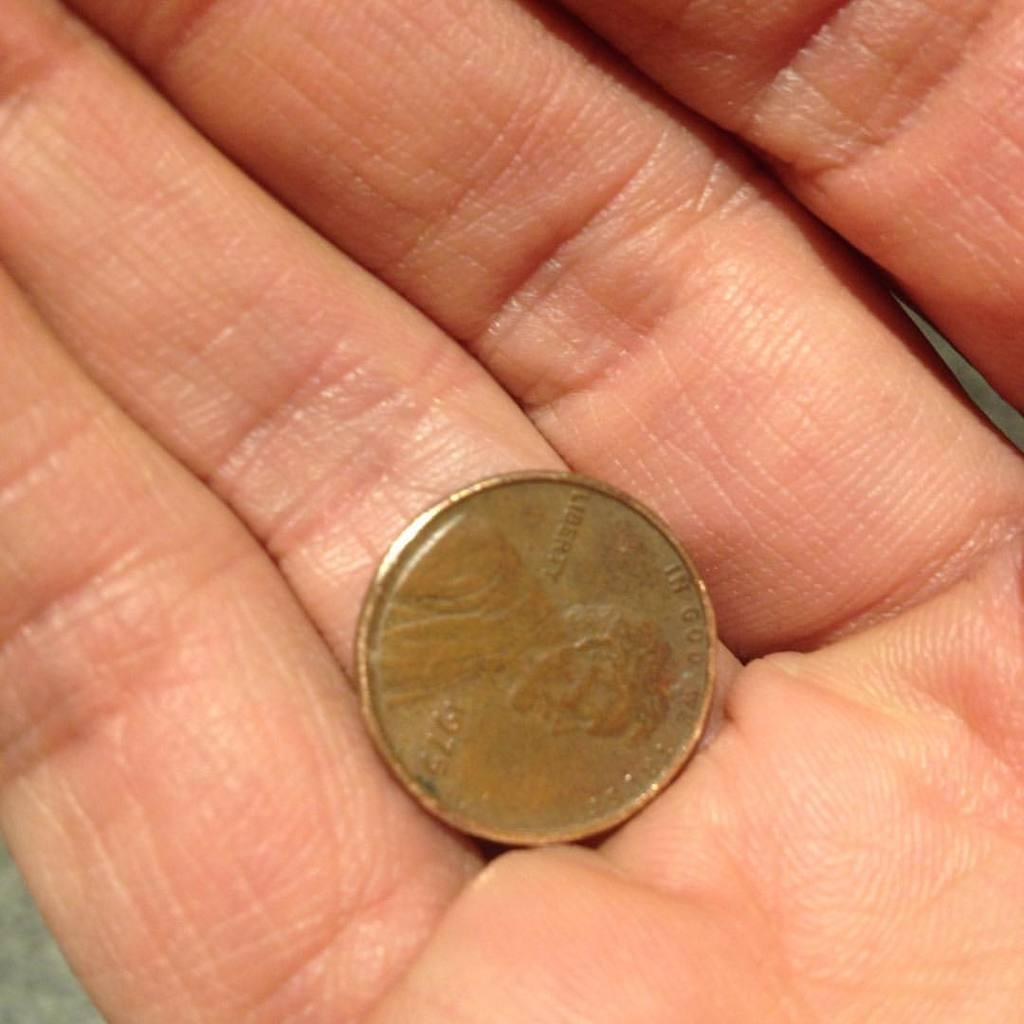Provide a one-sentence caption for the provided image. A hand holding a United States Penny from 1975. 